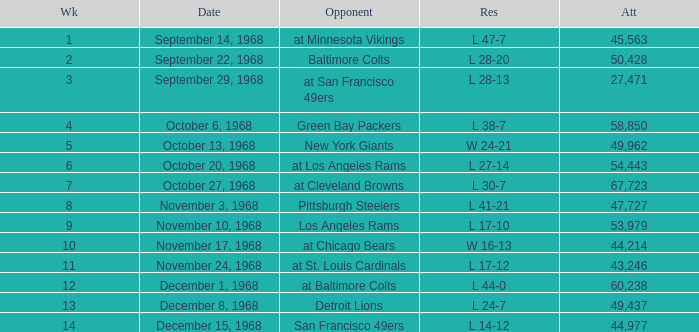Which Attendance has a Date of september 29, 1968, and a Week smaller than 3? None. 